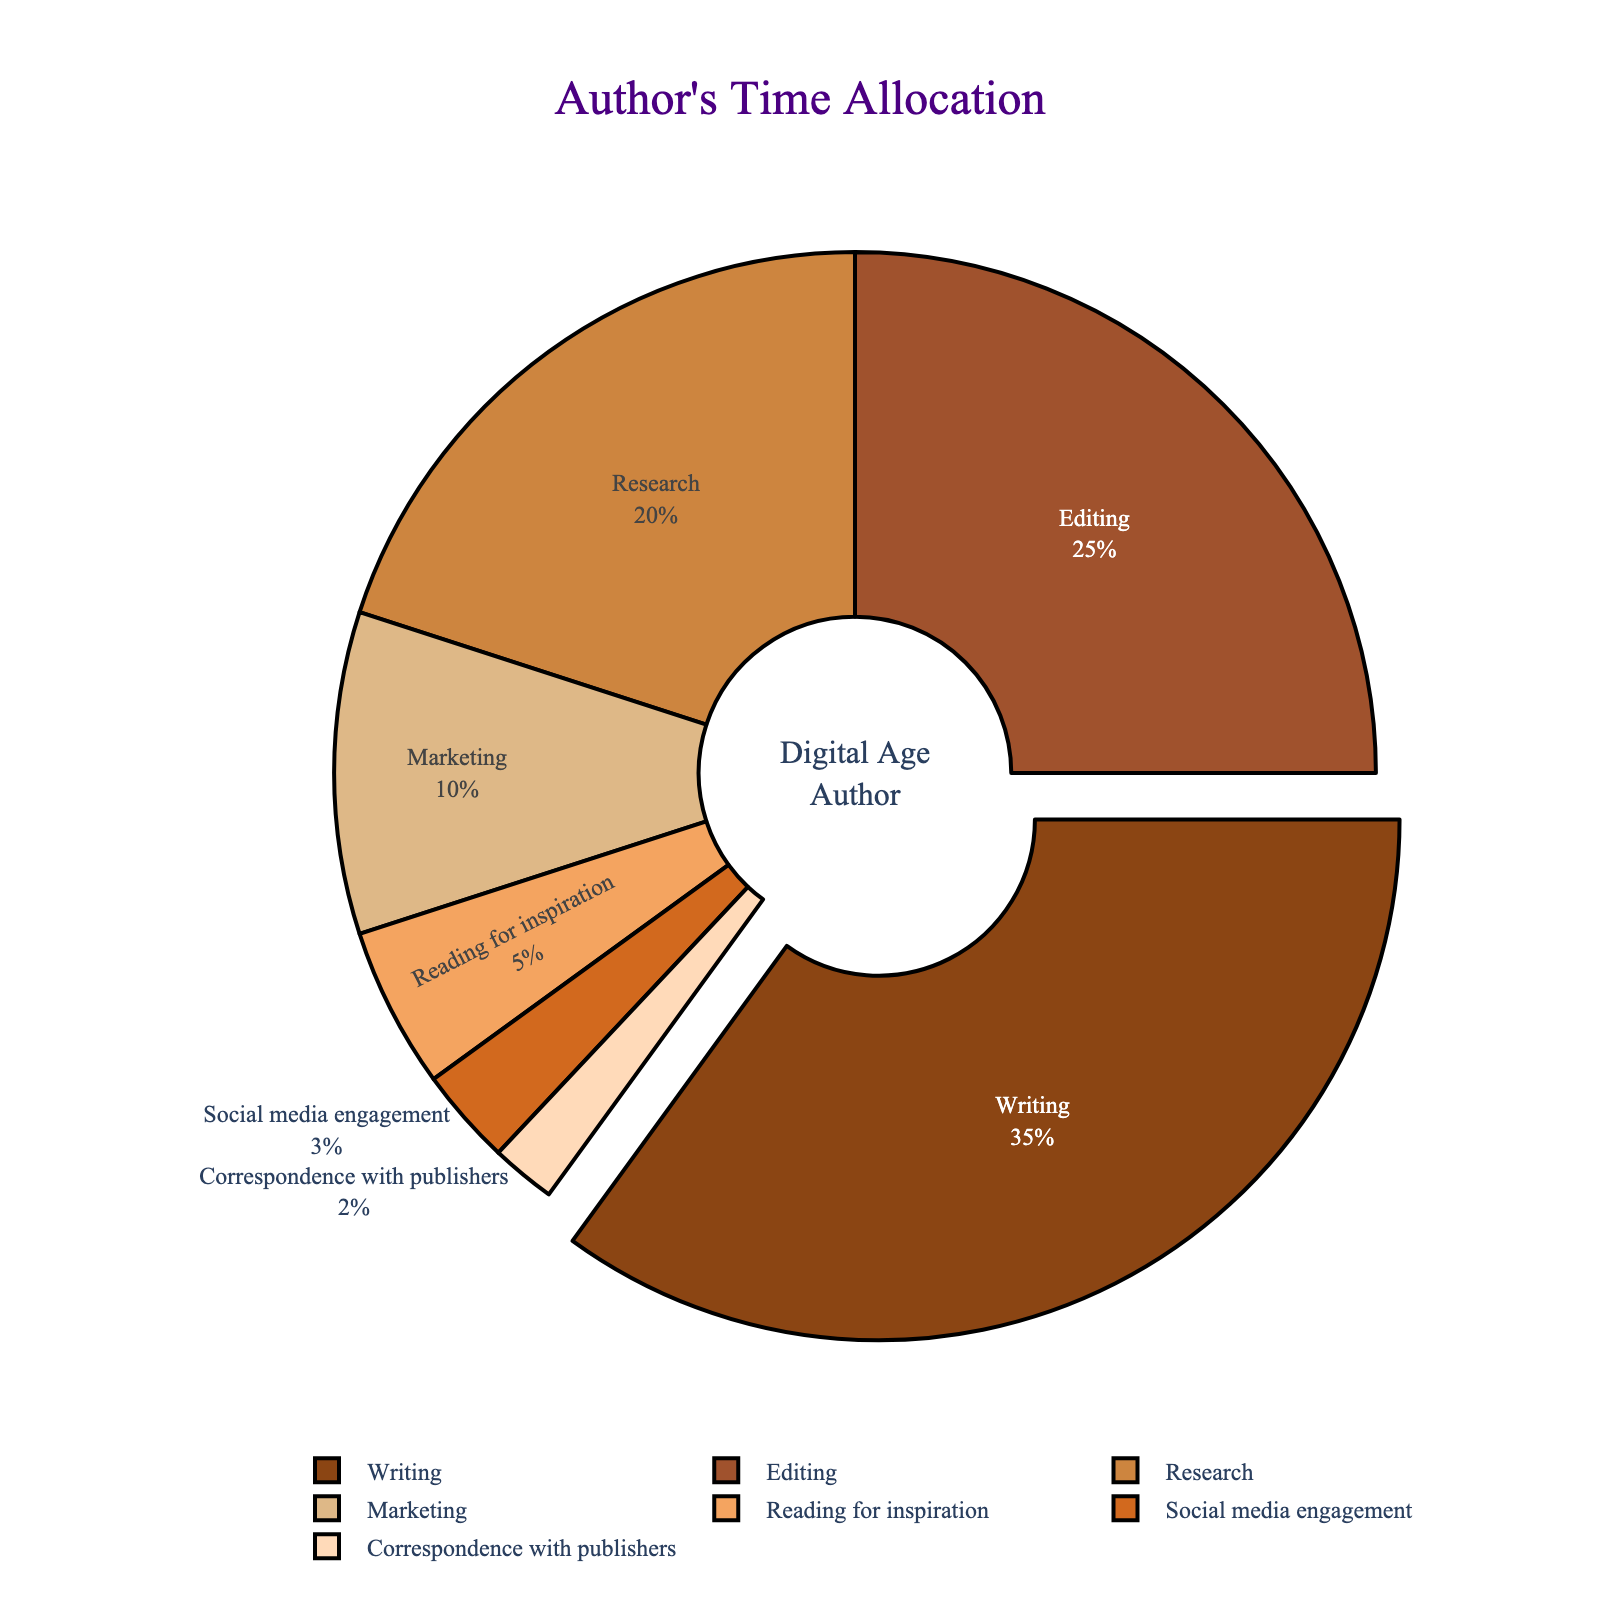What task do authors spend the most time on? The slice that is pulled out from the pie chart represents the task authors spend the most time on, which is labeled as "Writing" with 35% of the time allocation.
Answer: Writing What task is the least time-consuming for authors? The smallest slice in the pie chart corresponds to "Correspondence with publishers," which has a 2% time allocation.
Answer: Correspondence with publishers How much more time do authors spend on writing compared to marketing? Authors spend 35% of their time writing and 10% on marketing. The difference in time spent is 35% - 10% = 25%.
Answer: 25% What is the total percentage of time spent on non-writing tasks (editing, research, marketing, reading for inspiration, social media engagement, and correspondence with publishers)? Sum the percentages of the specified tasks: 25% (editing) + 20% (research) + 10% (marketing) + 5% (reading for inspiration) + 3% (social media engagement) + 2% (correspondence with publishers) = 65%.
Answer: 65% How does the time spent on social media engagement compare to the time spent on reading for inspiration? Social media engagement occupies 3% of the time while reading for inspiration is 5%. Reading for inspiration is 2% more than social media engagement.
Answer: Reading for inspiration is 2% more What is the visual attribute used to highlight the most time-consuming task? The most time-consuming task, "Writing," is highlighted by being slightly pulled out from the pie chart compared to other slices.
Answer: Pulled out If the slice for editing were to be colored in brown, what would be the position of this colored slice in the clockwise direction from the top? From the top of the pie chart (rotation start at 90 degrees), the second largest slice is "Editing," which should be positioned in its ordered place as per the chart's design for visual clarity.
Answer: Second What is the difference in the combined percentage of time spent on editing and research compared to writing? Combined time spent on editing and research is 25% + 20% = 45%. Difference with writing is 45% - 35% = 10%.
Answer: 10% Which tasks together make up one-third of the time allocation of authors? The combined time for reading for inspiration (5%), social media engagement (3%), and correspondence with publishers (2%) is 5% + 3% + 2% = 10%, which is one-third of the time allocation for marketing (10%).
Answer: Reading for inspiration, social media engagement, and correspondence with publishers How is the percentage of time spent on research visually distinguished from other slices? The slice for research is distinctively colored in a unique shade different from other tasks.
Answer: Unique color 